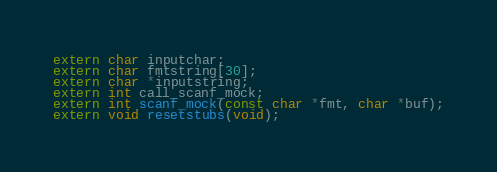Convert code to text. <code><loc_0><loc_0><loc_500><loc_500><_C_>
extern char inputchar;
extern char fmtstring[30];
extern char *inputstring;
extern int call_scanf_mock;
extern int scanf_mock(const char *fmt, char *buf);
extern void resetstubs(void);</code> 